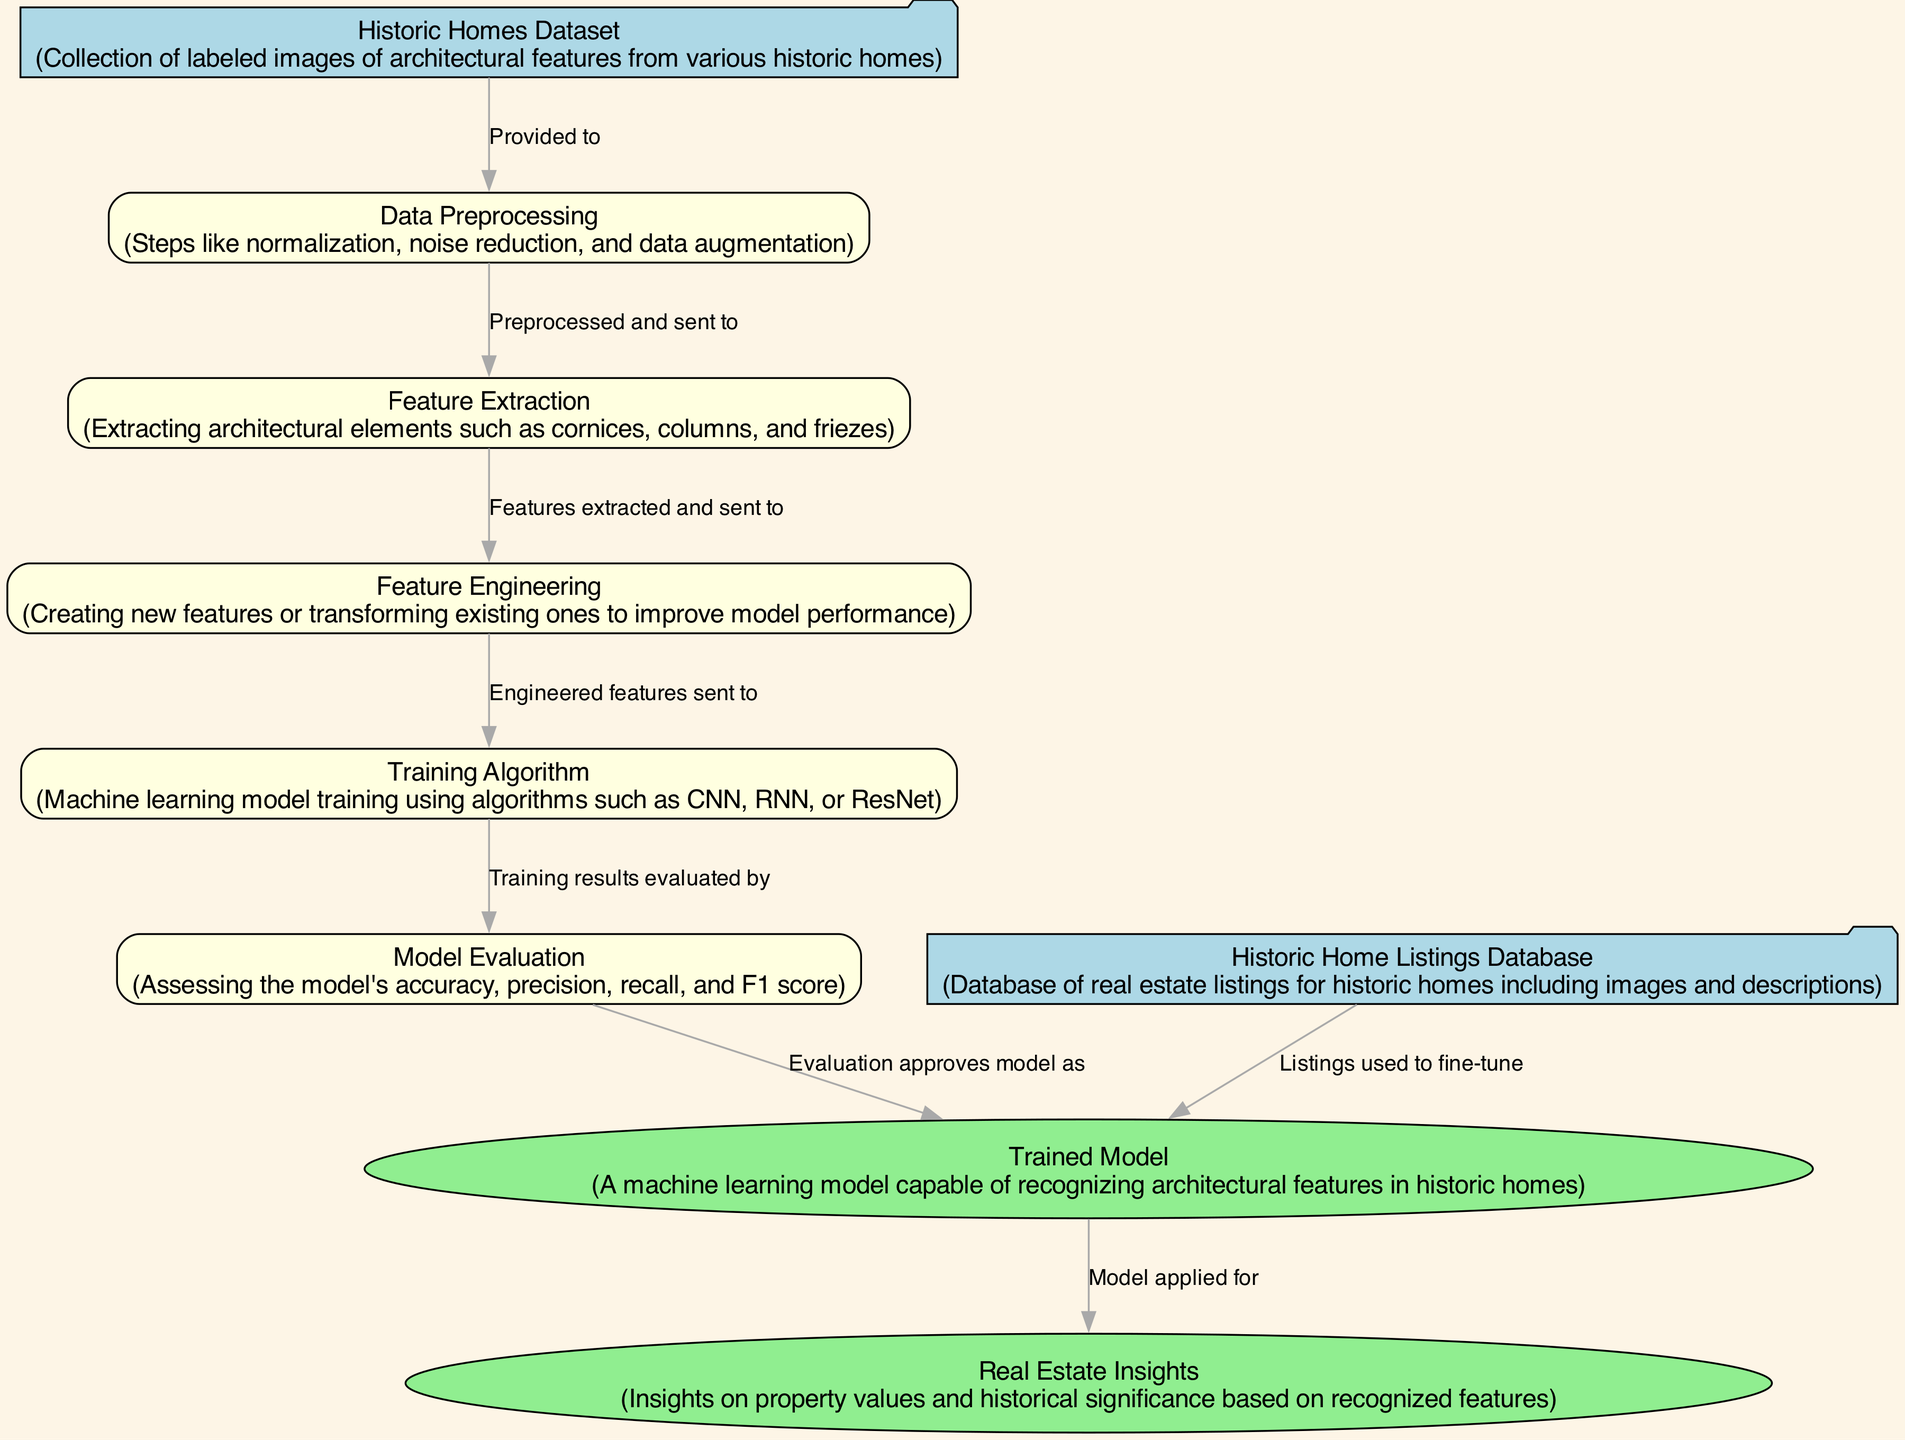What is the first input node in the diagram? The first input node is labeled "Historic Homes Dataset," which is indicated as the starting point for the processes that follow.
Answer: Historic Homes Dataset How many processes are shown in the diagram? The diagram includes five process nodes: Data Preprocessing, Feature Extraction, Feature Engineering, Training Algorithm, and Model Evaluation. By counting the nodes, we confirm the total number of processes.
Answer: Five What does the "Trained Model" output represent? The "Trained Model" output node represents a machine learning model capable of recognizing architectural features in historic homes. This is the primary result of the preceding processes in the diagram.
Answer: A machine learning model capable of recognizing architectural features in historic homes Which node is responsible for extracting architectural elements? The node labeled "Feature Extraction" is responsible for extracting architectural elements such as cornices, columns, and friezes, as stated in its description.
Answer: Feature Extraction What is the relationship between the "Model Evaluation" and "Trained Model" nodes? The relationship is that "Model Evaluation" assesses the outputs of the "Training Algorithm," and upon successful evaluation, the model is approved and labeled as the "Trained Model." This illustrates the flow of data from evaluation to final output.
Answer: Evaluates How are the "Historic Home Listings Database" and the "Trained Model" connected? The "Historic Home Listings Database" provides data that is used to fine-tune the "Trained Model," indicating that listings are utilized to improve its performance. Therefore, the listings are essential for the continuous improvement of the model.
Answer: Fine-tune What is the main purpose of the "Real Estate Insights" output? The main purpose of the "Real Estate Insights" output is to provide insights on property values and historical significance based on the features recognized by the trained model. It serves as the practical application of the model's results.
Answer: Insights on property values and historical significance Which process comes after "Data Preprocessing"? After "Data Preprocessing," the next process in the sequence is "Feature Extraction," as shown by the flow of arrows in the diagram connecting these nodes.
Answer: Feature Extraction What machine learning algorithms are mentioned for the "Training Algorithm"? The "Training Algorithm" mentions several machine learning algorithms: CNN, RNN, or ResNet, which are specified in its description as options for training the model.
Answer: CNN, RNN, or ResNet 